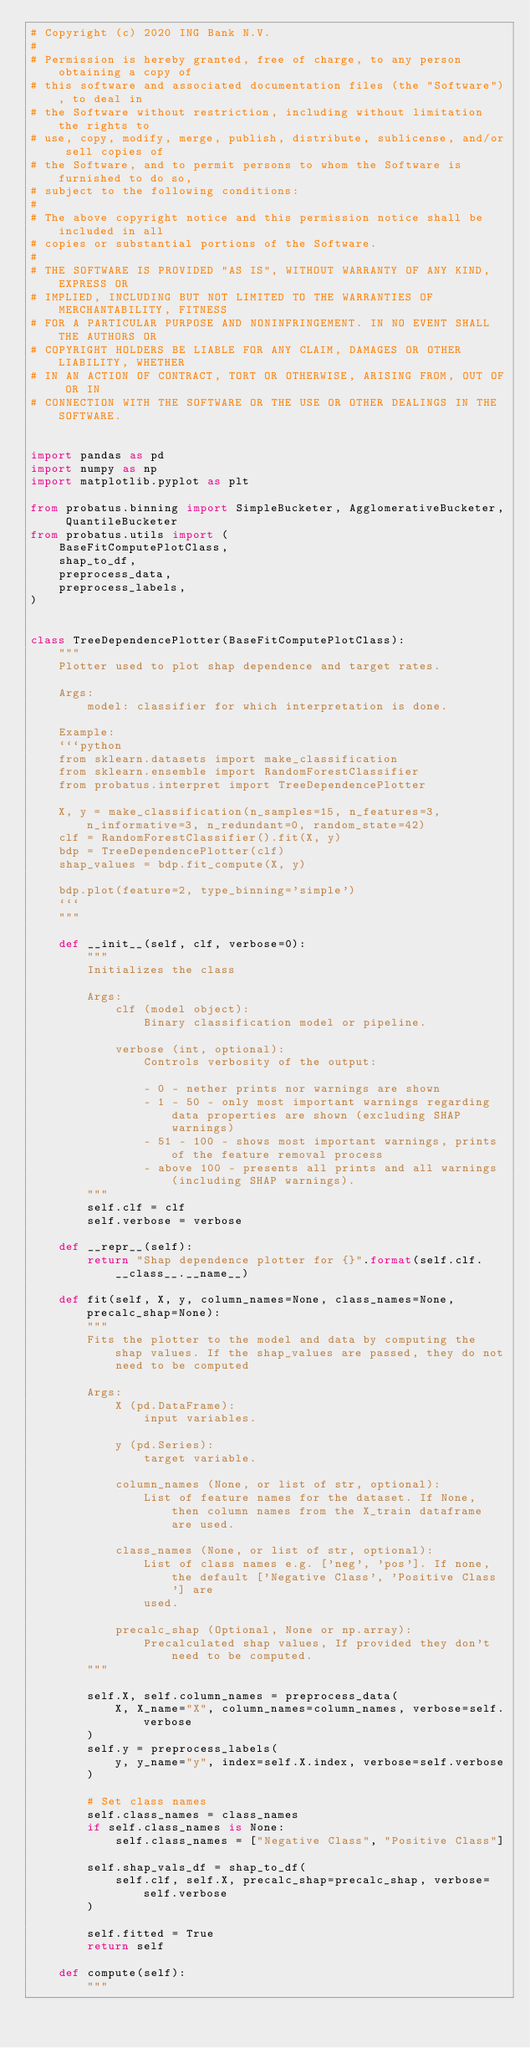Convert code to text. <code><loc_0><loc_0><loc_500><loc_500><_Python_># Copyright (c) 2020 ING Bank N.V.
#
# Permission is hereby granted, free of charge, to any person obtaining a copy of
# this software and associated documentation files (the "Software"), to deal in
# the Software without restriction, including without limitation the rights to
# use, copy, modify, merge, publish, distribute, sublicense, and/or sell copies of
# the Software, and to permit persons to whom the Software is furnished to do so,
# subject to the following conditions:
#
# The above copyright notice and this permission notice shall be included in all
# copies or substantial portions of the Software.
#
# THE SOFTWARE IS PROVIDED "AS IS", WITHOUT WARRANTY OF ANY KIND, EXPRESS OR
# IMPLIED, INCLUDING BUT NOT LIMITED TO THE WARRANTIES OF MERCHANTABILITY, FITNESS
# FOR A PARTICULAR PURPOSE AND NONINFRINGEMENT. IN NO EVENT SHALL THE AUTHORS OR
# COPYRIGHT HOLDERS BE LIABLE FOR ANY CLAIM, DAMAGES OR OTHER LIABILITY, WHETHER
# IN AN ACTION OF CONTRACT, TORT OR OTHERWISE, ARISING FROM, OUT OF OR IN
# CONNECTION WITH THE SOFTWARE OR THE USE OR OTHER DEALINGS IN THE SOFTWARE.


import pandas as pd
import numpy as np
import matplotlib.pyplot as plt

from probatus.binning import SimpleBucketer, AgglomerativeBucketer, QuantileBucketer
from probatus.utils import (
    BaseFitComputePlotClass,
    shap_to_df,
    preprocess_data,
    preprocess_labels,
)


class TreeDependencePlotter(BaseFitComputePlotClass):
    """
    Plotter used to plot shap dependence and target rates.

    Args:
        model: classifier for which interpretation is done.

    Example:
    ```python
    from sklearn.datasets import make_classification
    from sklearn.ensemble import RandomForestClassifier
    from probatus.interpret import TreeDependencePlotter

    X, y = make_classification(n_samples=15, n_features=3, n_informative=3, n_redundant=0, random_state=42)
    clf = RandomForestClassifier().fit(X, y)
    bdp = TreeDependencePlotter(clf)
    shap_values = bdp.fit_compute(X, y)

    bdp.plot(feature=2, type_binning='simple')
    ```
    """

    def __init__(self, clf, verbose=0):
        """
        Initializes the class

        Args:
            clf (model object):
                Binary classification model or pipeline.

            verbose (int, optional):
                Controls verbosity of the output:

                - 0 - nether prints nor warnings are shown
                - 1 - 50 - only most important warnings regarding data properties are shown (excluding SHAP warnings)
                - 51 - 100 - shows most important warnings, prints of the feature removal process
                - above 100 - presents all prints and all warnings (including SHAP warnings).
        """
        self.clf = clf
        self.verbose = verbose

    def __repr__(self):
        return "Shap dependence plotter for {}".format(self.clf.__class__.__name__)

    def fit(self, X, y, column_names=None, class_names=None, precalc_shap=None):
        """
        Fits the plotter to the model and data by computing the shap values. If the shap_values are passed, they do not
            need to be computed

        Args:
            X (pd.DataFrame):
                input variables.

            y (pd.Series):
                target variable.

            column_names (None, or list of str, optional):
                List of feature names for the dataset. If None, then column names from the X_train dataframe are used.

            class_names (None, or list of str, optional):
                List of class names e.g. ['neg', 'pos']. If none, the default ['Negative Class', 'Positive Class'] are
                used.

            precalc_shap (Optional, None or np.array):
                Precalculated shap values, If provided they don't need to be computed.
        """

        self.X, self.column_names = preprocess_data(
            X, X_name="X", column_names=column_names, verbose=self.verbose
        )
        self.y = preprocess_labels(
            y, y_name="y", index=self.X.index, verbose=self.verbose
        )

        # Set class names
        self.class_names = class_names
        if self.class_names is None:
            self.class_names = ["Negative Class", "Positive Class"]

        self.shap_vals_df = shap_to_df(
            self.clf, self.X, precalc_shap=precalc_shap, verbose=self.verbose
        )

        self.fitted = True
        return self

    def compute(self):
        """</code> 